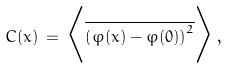Convert formula to latex. <formula><loc_0><loc_0><loc_500><loc_500>C ( x ) \, = \, \Big < \overline { \left ( \varphi ( x ) - \varphi ( 0 ) \right ) ^ { 2 } } \Big > \, ,</formula> 